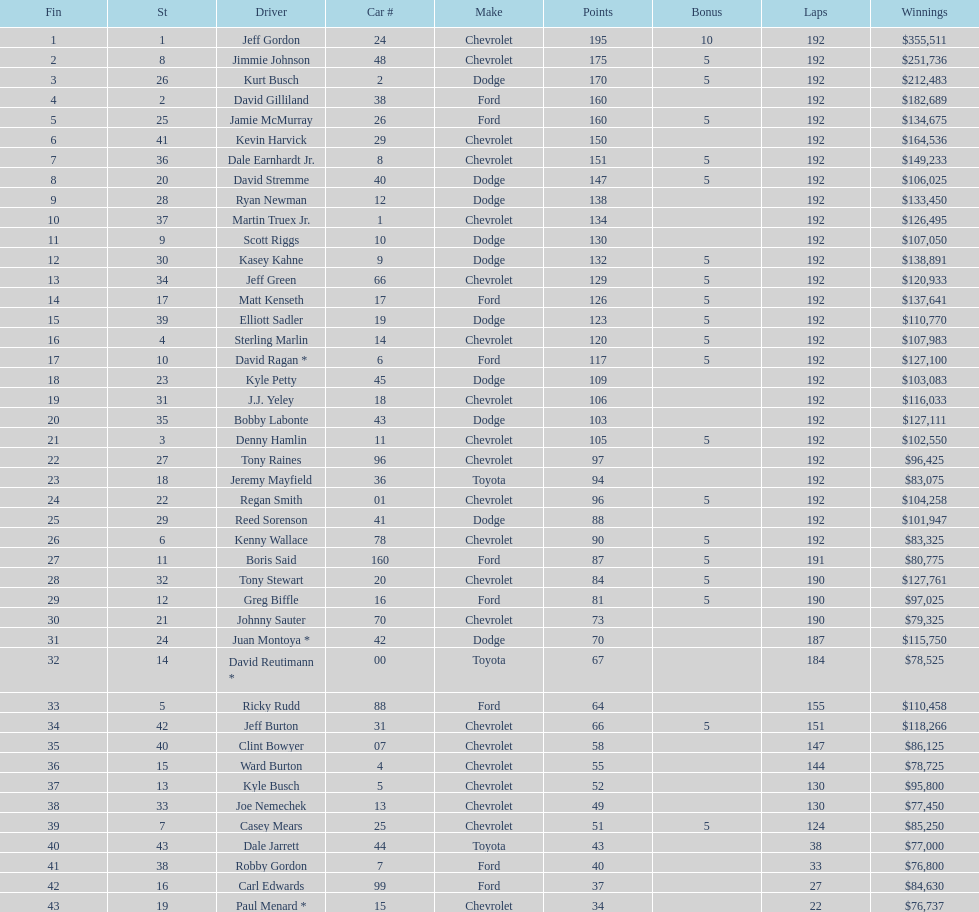What was the amount won by jimmie johnson? $251,736. 